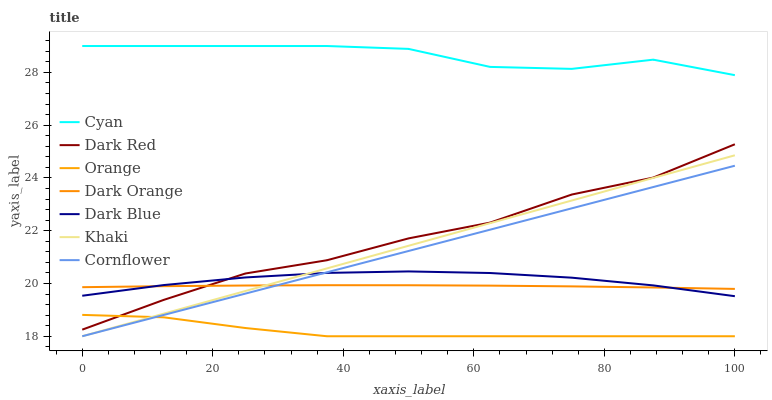Does Orange have the minimum area under the curve?
Answer yes or no. Yes. Does Cyan have the maximum area under the curve?
Answer yes or no. Yes. Does Khaki have the minimum area under the curve?
Answer yes or no. No. Does Khaki have the maximum area under the curve?
Answer yes or no. No. Is Cornflower the smoothest?
Answer yes or no. Yes. Is Dark Red the roughest?
Answer yes or no. Yes. Is Khaki the smoothest?
Answer yes or no. No. Is Khaki the roughest?
Answer yes or no. No. Does Khaki have the lowest value?
Answer yes or no. Yes. Does Dark Red have the lowest value?
Answer yes or no. No. Does Cyan have the highest value?
Answer yes or no. Yes. Does Khaki have the highest value?
Answer yes or no. No. Is Dark Orange less than Cyan?
Answer yes or no. Yes. Is Cyan greater than Khaki?
Answer yes or no. Yes. Does Dark Red intersect Dark Blue?
Answer yes or no. Yes. Is Dark Red less than Dark Blue?
Answer yes or no. No. Is Dark Red greater than Dark Blue?
Answer yes or no. No. Does Dark Orange intersect Cyan?
Answer yes or no. No. 